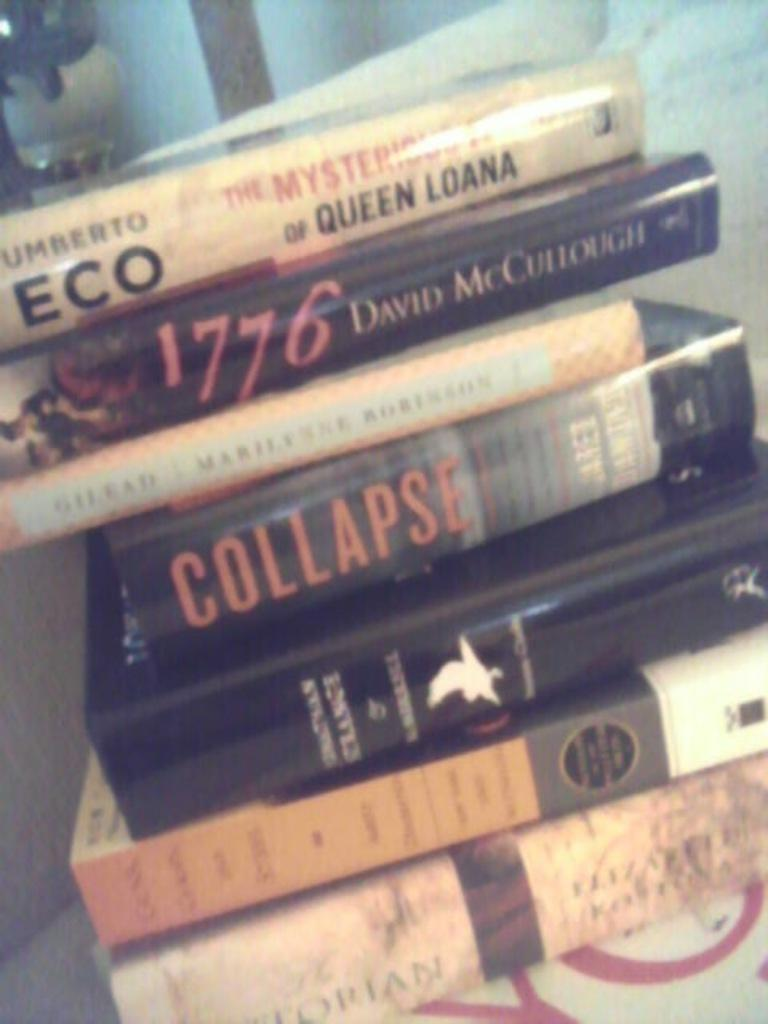<image>
Relay a brief, clear account of the picture shown. A stack of books including The Mysterious Flame of Queen Loana by Umberto Eco and 1776 by David McCullough. 